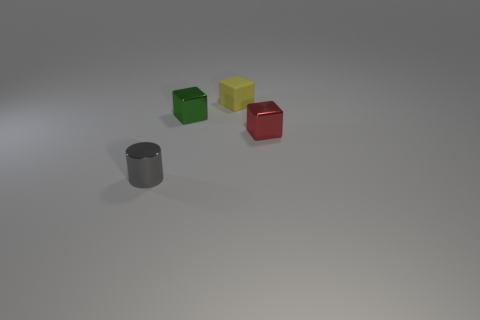Add 1 green things. How many objects exist? 5 Subtract all small matte blocks. How many blocks are left? 2 Subtract 1 cylinders. How many cylinders are left? 0 Subtract all cylinders. How many objects are left? 3 Subtract all yellow cubes. How many cubes are left? 2 Subtract all brown cubes. Subtract all cyan balls. How many cubes are left? 3 Subtract all red cubes. How many red cylinders are left? 0 Subtract all green shiny blocks. Subtract all green metallic objects. How many objects are left? 2 Add 1 gray objects. How many gray objects are left? 2 Add 2 tiny shiny cylinders. How many tiny shiny cylinders exist? 3 